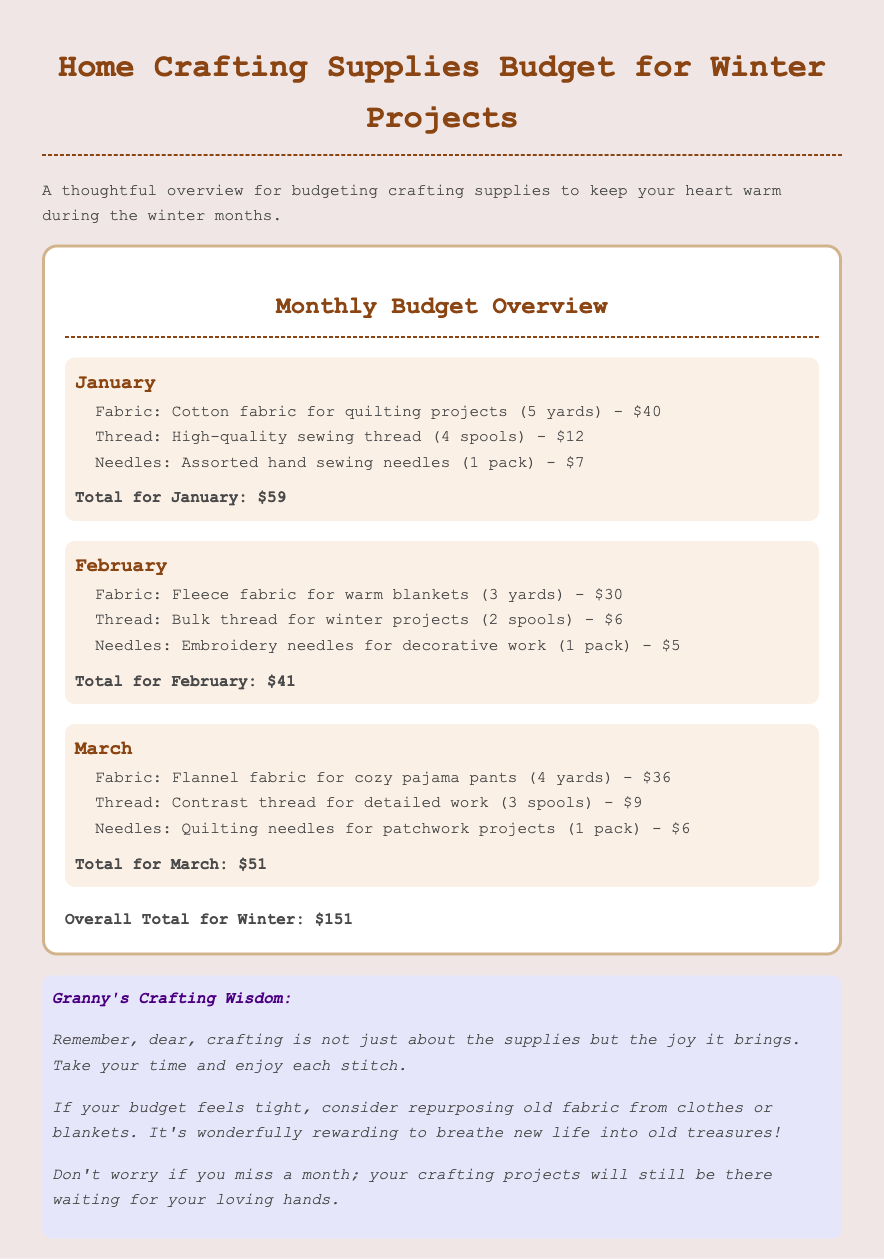What is the total fabric expense for January? The fabric expense for January is $40, which is the only fabric listed for that month.
Answer: $40 What type of fabric is purchased in February? The document states that fleece fabric is purchased for warm blankets in February.
Answer: Fleece How many spools of thread are bought in March? For March, the document lists that 3 spools of contrast thread are bought.
Answer: 3 spools What is the total expense for February? The total expense for February is calculated as $30 (fabric) + $6 (thread) + $5 (needles) = $41.
Answer: $41 Which month has the highest total expenditure? By comparing the totals, January has the highest expenditure at $59.
Answer: January How many yards of fabric are bought for cozy pajama pants in March? The document indicates that 4 yards of flannel fabric are bought for March's pajama pants.
Answer: 4 yards What is the overall total for the winter budget? The overall total for all months combined is stated as $151 in the document.
Answer: $151 What type of needles are purchased in February? The document specifies embroidery needles are bought for decorative work in February.
Answer: Embroidery needles What is the title of the advice section? The title of the advice section is "Granny's Crafting Wisdom."
Answer: Granny's Crafting Wisdom 